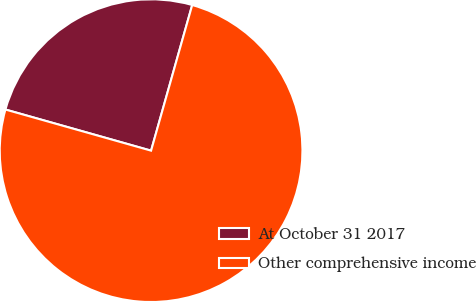Convert chart. <chart><loc_0><loc_0><loc_500><loc_500><pie_chart><fcel>At October 31 2017<fcel>Other comprehensive income<nl><fcel>25.0%<fcel>75.0%<nl></chart> 